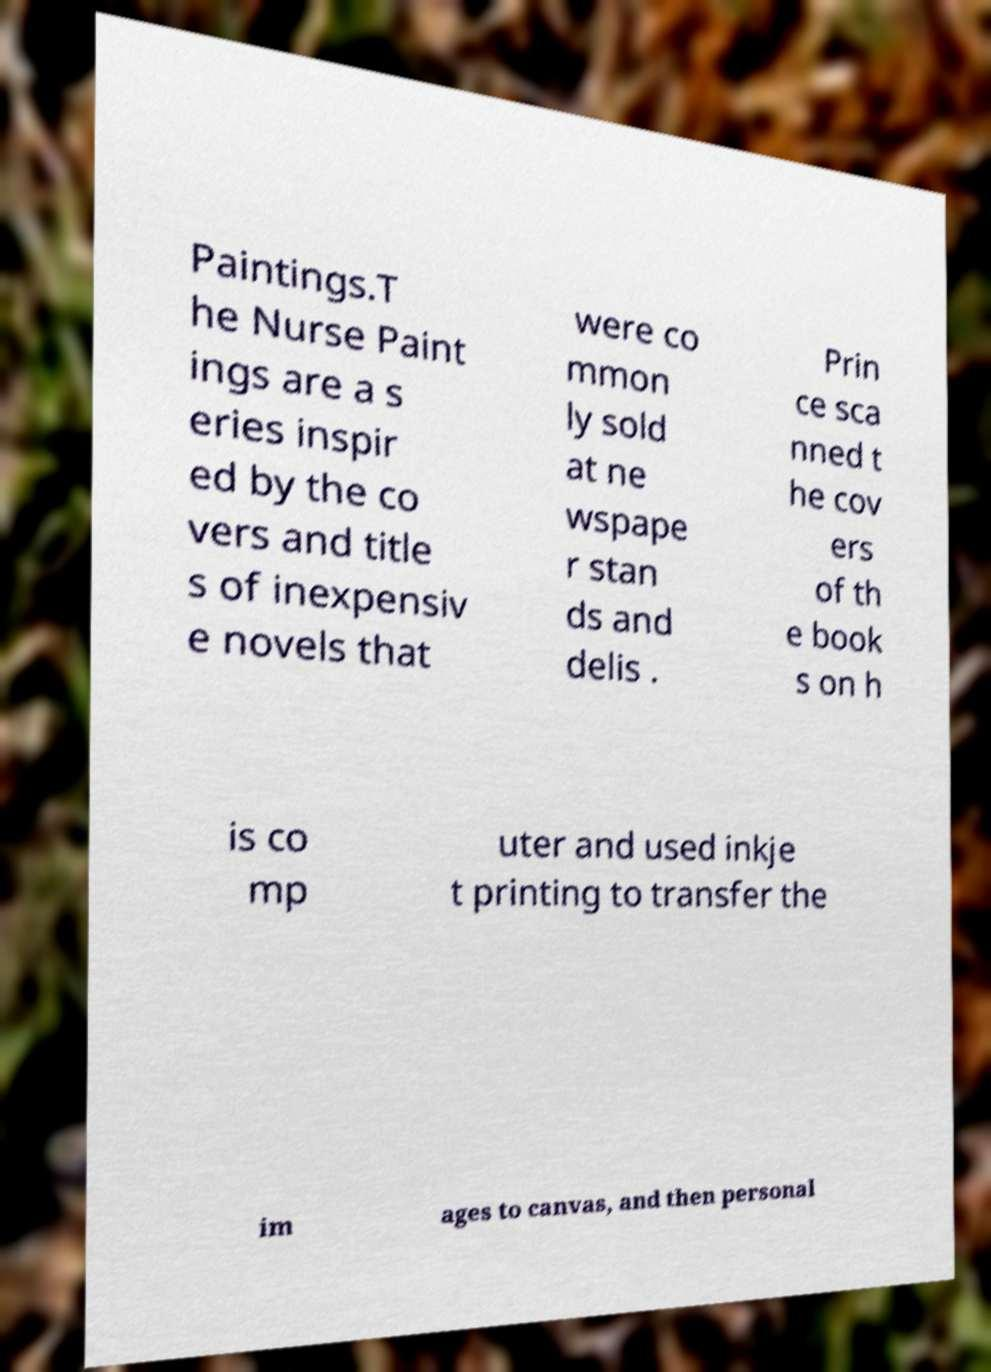Could you extract and type out the text from this image? Paintings.T he Nurse Paint ings are a s eries inspir ed by the co vers and title s of inexpensiv e novels that were co mmon ly sold at ne wspape r stan ds and delis . Prin ce sca nned t he cov ers of th e book s on h is co mp uter and used inkje t printing to transfer the im ages to canvas, and then personal 